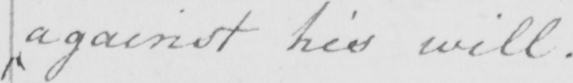What is written in this line of handwriting? against his will . 